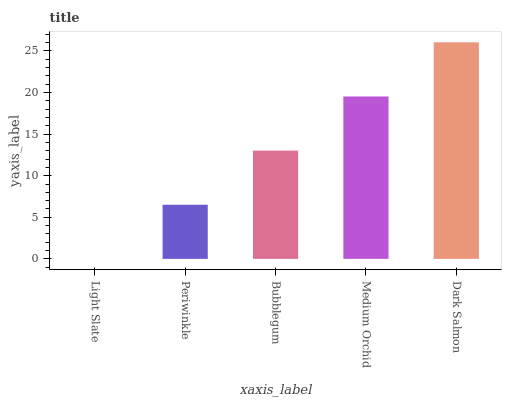Is Light Slate the minimum?
Answer yes or no. Yes. Is Dark Salmon the maximum?
Answer yes or no. Yes. Is Periwinkle the minimum?
Answer yes or no. No. Is Periwinkle the maximum?
Answer yes or no. No. Is Periwinkle greater than Light Slate?
Answer yes or no. Yes. Is Light Slate less than Periwinkle?
Answer yes or no. Yes. Is Light Slate greater than Periwinkle?
Answer yes or no. No. Is Periwinkle less than Light Slate?
Answer yes or no. No. Is Bubblegum the high median?
Answer yes or no. Yes. Is Bubblegum the low median?
Answer yes or no. Yes. Is Medium Orchid the high median?
Answer yes or no. No. Is Light Slate the low median?
Answer yes or no. No. 